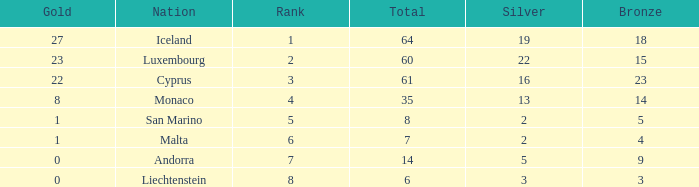How many bronzes for Iceland with over 2 silvers? 18.0. 